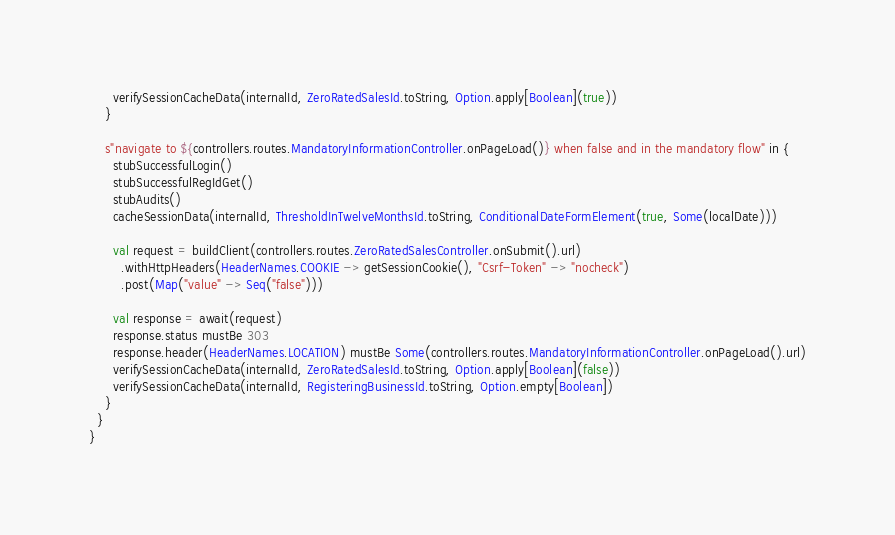<code> <loc_0><loc_0><loc_500><loc_500><_Scala_>      verifySessionCacheData(internalId, ZeroRatedSalesId.toString, Option.apply[Boolean](true))
    }

    s"navigate to ${controllers.routes.MandatoryInformationController.onPageLoad()} when false and in the mandatory flow" in {
      stubSuccessfulLogin()
      stubSuccessfulRegIdGet()
      stubAudits()
      cacheSessionData(internalId, ThresholdInTwelveMonthsId.toString, ConditionalDateFormElement(true, Some(localDate)))

      val request = buildClient(controllers.routes.ZeroRatedSalesController.onSubmit().url)
        .withHttpHeaders(HeaderNames.COOKIE -> getSessionCookie(), "Csrf-Token" -> "nocheck")
        .post(Map("value" -> Seq("false")))

      val response = await(request)
      response.status mustBe 303
      response.header(HeaderNames.LOCATION) mustBe Some(controllers.routes.MandatoryInformationController.onPageLoad().url)
      verifySessionCacheData(internalId, ZeroRatedSalesId.toString, Option.apply[Boolean](false))
      verifySessionCacheData(internalId, RegisteringBusinessId.toString, Option.empty[Boolean])
    }
  }
}</code> 